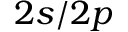Convert formula to latex. <formula><loc_0><loc_0><loc_500><loc_500>2 s / 2 p</formula> 